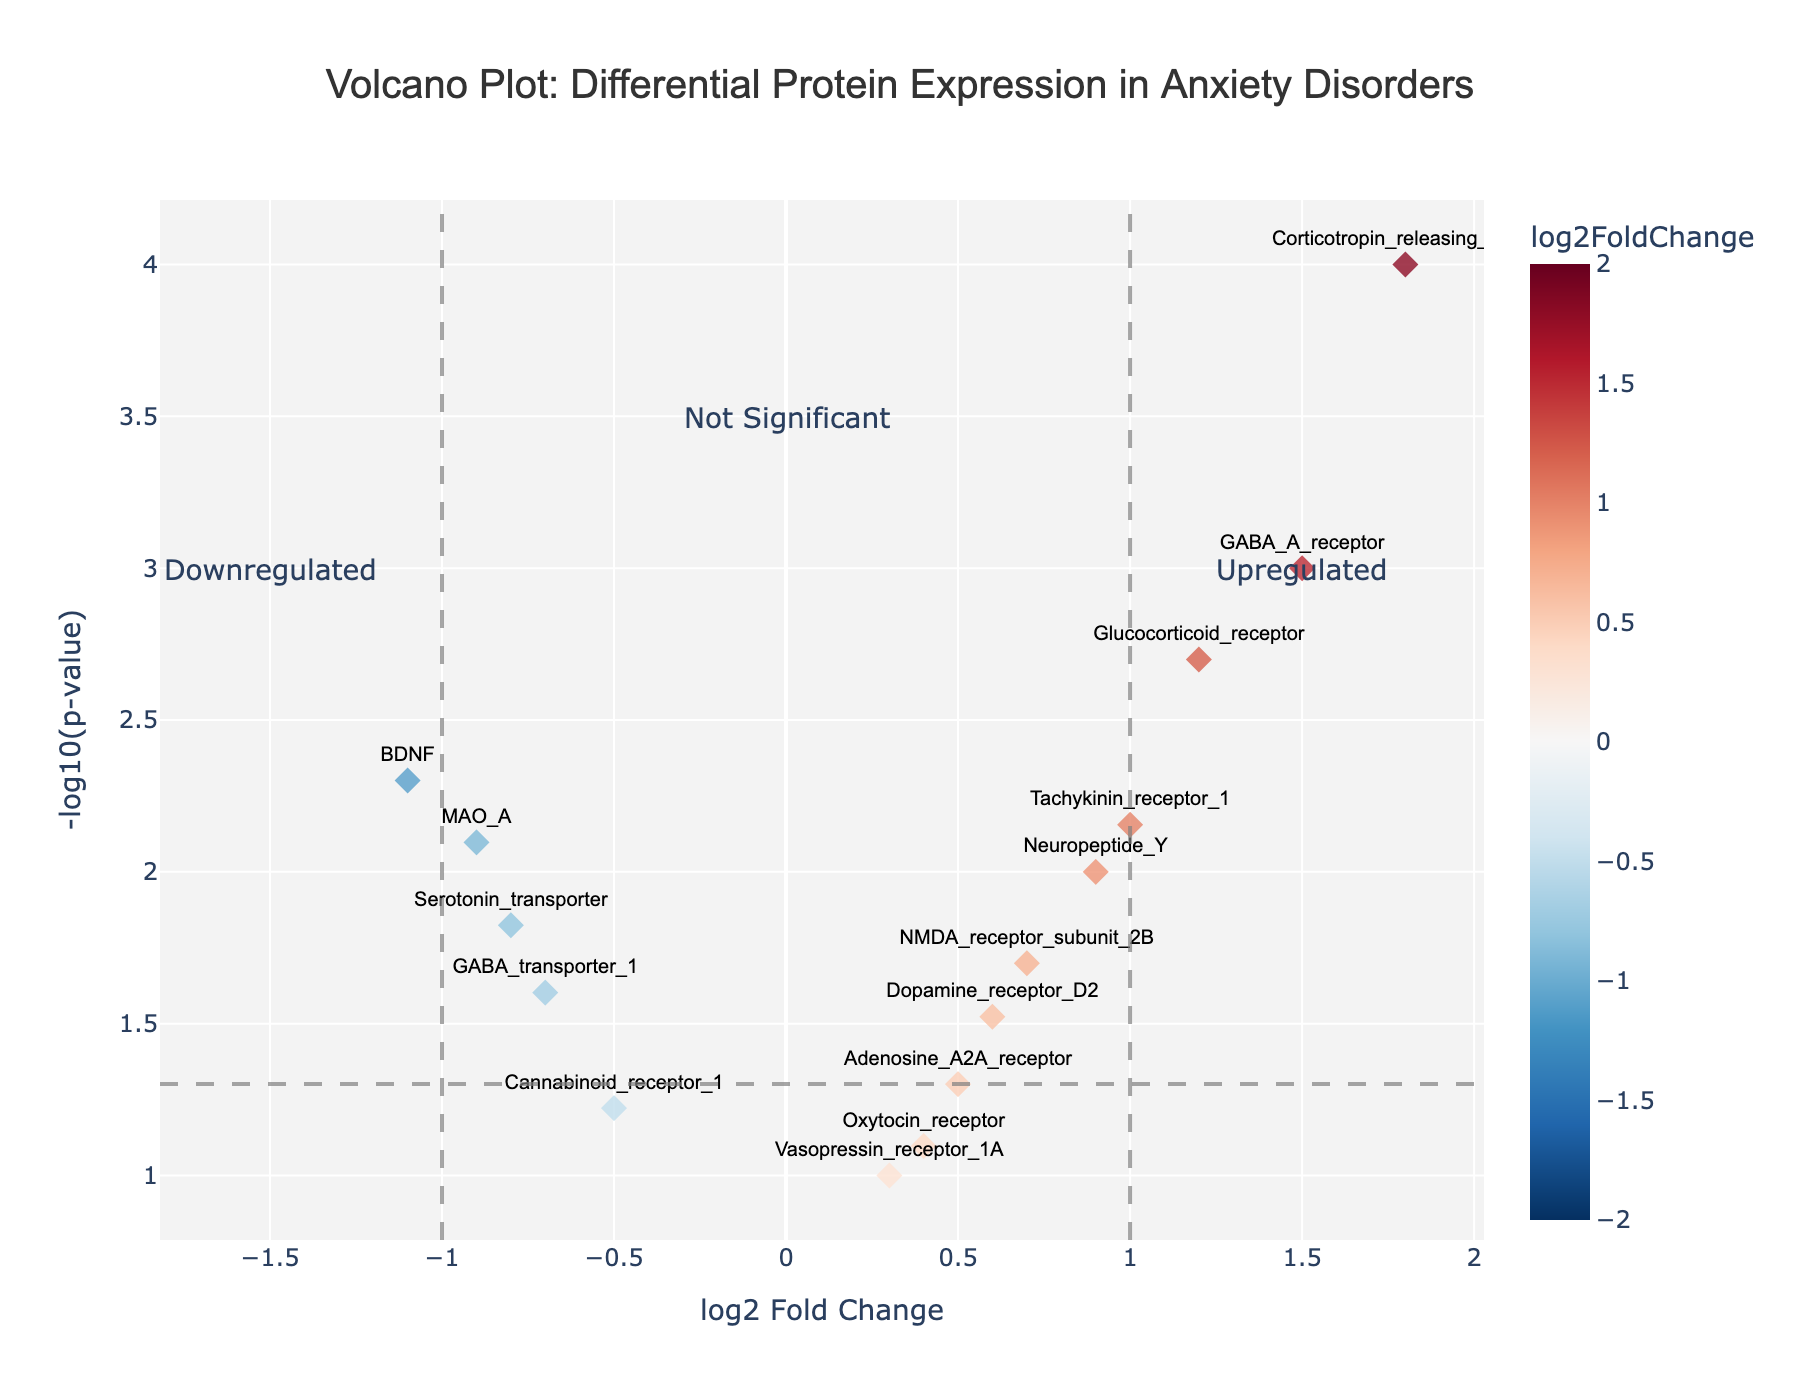What is the title of the volcano plot? The title of the volcano plot is usually located at the top of the figure, which is quite large and easily readable. From the plot description, it states, "Volcano Plot: Differential Protein Expression in Anxiety Disorders".
Answer: Volcano Plot: Differential Protein Expression in Anxiety Disorders Which axis represents the log2 fold change in the volcano plot? In the plot, the x-axis is typically used to represent the log2 fold change, as highlighted in the provided data and code. The label for the x-axis reads "log2 Fold Change".
Answer: x-axis How many proteins are significantly upregulated (log2 fold change > 1 and p-value < 0.05)? Significantly upregulated proteins are those with a log2 fold change greater than 1 and p-value less than 0.05. Proteins meeting these criteria are GABA_A_receptor, Glucocorticoid_receptor, and Corticotropin_releasing_factor. Count them to get the answer.
Answer: 3 What is the -log10(p-value) threshold that indicates statistical significance in the plot? The -log10(p-value) threshold for statistical significance is shown by a horizontal line across the plot. This threshold is indicated at -log10(0.05), which is approximately 1.3.
Answer: 1.3 Which protein has the highest log2 fold change, and what is its value? The highest log2 fold change is identified by finding the protein farthest to the right on the x-axis. Corticotropin_releasing_factor has the highest log2 fold change of 1.8.
Answer: Corticotropin_releasing_factor, 1.8 Are there any proteins that are downregulated (log2 fold change < -1) and statistically significant (p-value < 0.05)? Downregulated and statistically significant proteins are found by looking in the lower left section of the plot. BDNF is the only protein that meets both criteria with log2 fold change of -1.1 and p-value of 0.005.
Answer: Yes, BDNF Which two proteins have similar log2 fold change values but differ in their statistical significance? To find proteins with similar log2 fold change but differing in statistical significance, compare the proteins' positions on the x-axis and their heights on the y-axis. Serotonin_transporter and GABA_transporter_1 both have log2 fold changes close to -0.8 and -0.7 respectively, but Serotonin_transporter is more statistically significant than GABA_transporter_1.
Answer: Serotonin_transporter and GABA_transporter_1 What does the color gradient in the volcano plot represent? The color gradient in the plot varies based on the log2 fold change values, with a continuous scale reflecting the upregulation or downregulation. Specifically, from the data, the color changes in the spectrum of "RdBu_r" indicating the range from upregulated (red) to downregulated (blue).
Answer: log2 fold change What can be inferred about proteins having log2 fold changes between -1 and 1 and p-values greater than 0.05? Proteins in this range are located near the center of the plot and below the statistical significance threshold. These proteins are not considered significantly upregulated or downregulated, implying they are likely not differentially expressed between individuals with and without anxiety disorders.
Answer: Not significantly differentially expressed 